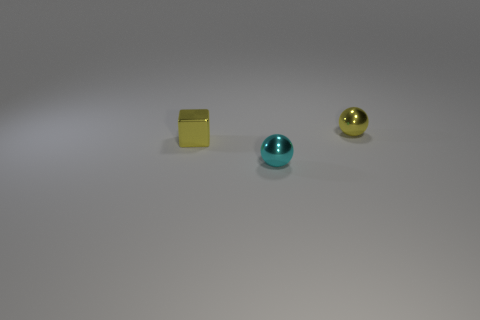What is the material of the other thing that is the same shape as the cyan thing?
Provide a short and direct response. Metal. Does the small cyan object have the same shape as the tiny yellow metallic thing to the right of the small cube?
Your answer should be compact. Yes. What color is the thing that is to the left of the yellow metal sphere and behind the tiny cyan thing?
Your response must be concise. Yellow. Are there any small yellow things?
Your answer should be compact. Yes. Is the number of small metallic spheres that are in front of the tiny cyan object the same as the number of yellow metal spheres?
Offer a very short reply. No. What number of other things are there of the same shape as the small cyan metal thing?
Give a very brief answer. 1. What is the shape of the cyan shiny thing?
Ensure brevity in your answer.  Sphere. Is the material of the small cyan thing the same as the tiny cube?
Provide a succinct answer. Yes. Are there the same number of yellow metal things that are behind the small yellow cube and small things that are behind the tiny cyan object?
Make the answer very short. No. Is there a small cyan shiny thing that is behind the shiny sphere that is on the left side of the tiny metal object behind the small block?
Your response must be concise. No. 